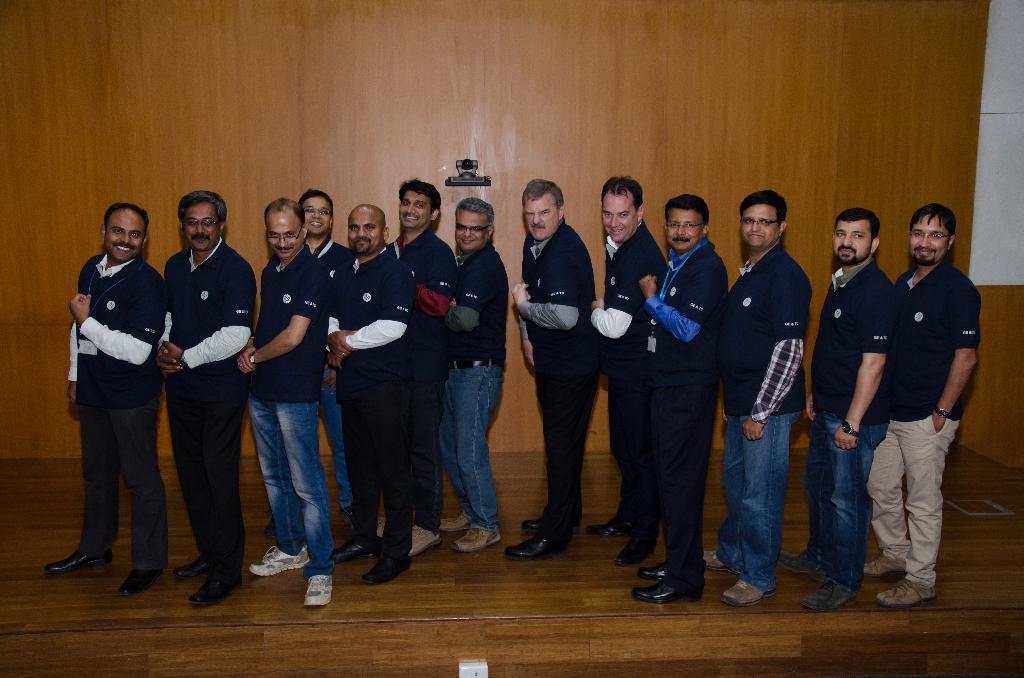Can you describe this image briefly? In this image in the foreground there are thirteen people standing on the stage and at the bottom there is a switch. 